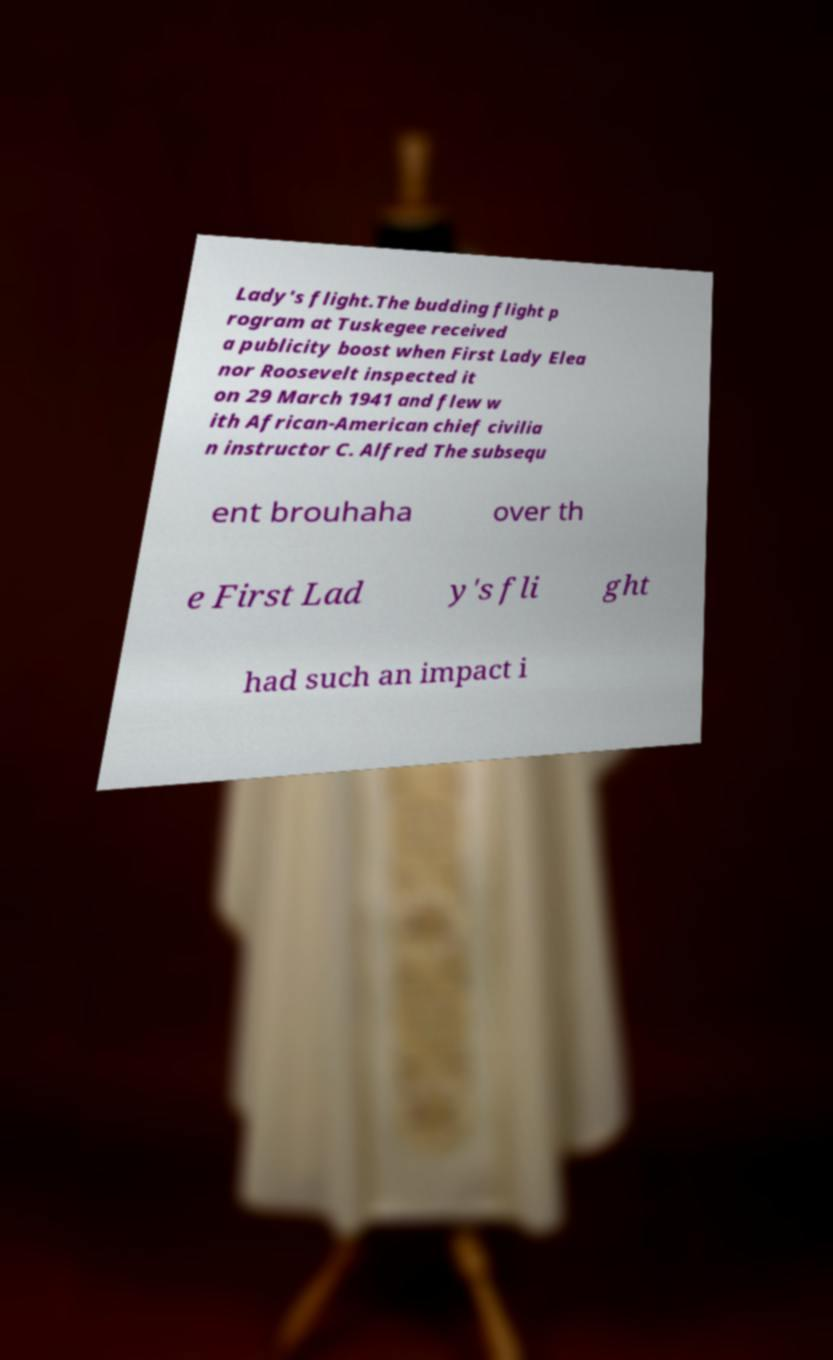I need the written content from this picture converted into text. Can you do that? Lady's flight.The budding flight p rogram at Tuskegee received a publicity boost when First Lady Elea nor Roosevelt inspected it on 29 March 1941 and flew w ith African-American chief civilia n instructor C. Alfred The subsequ ent brouhaha over th e First Lad y's fli ght had such an impact i 